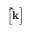Convert formula to latex. <formula><loc_0><loc_0><loc_500><loc_500>\left [ \hat { k } \right ]</formula> 